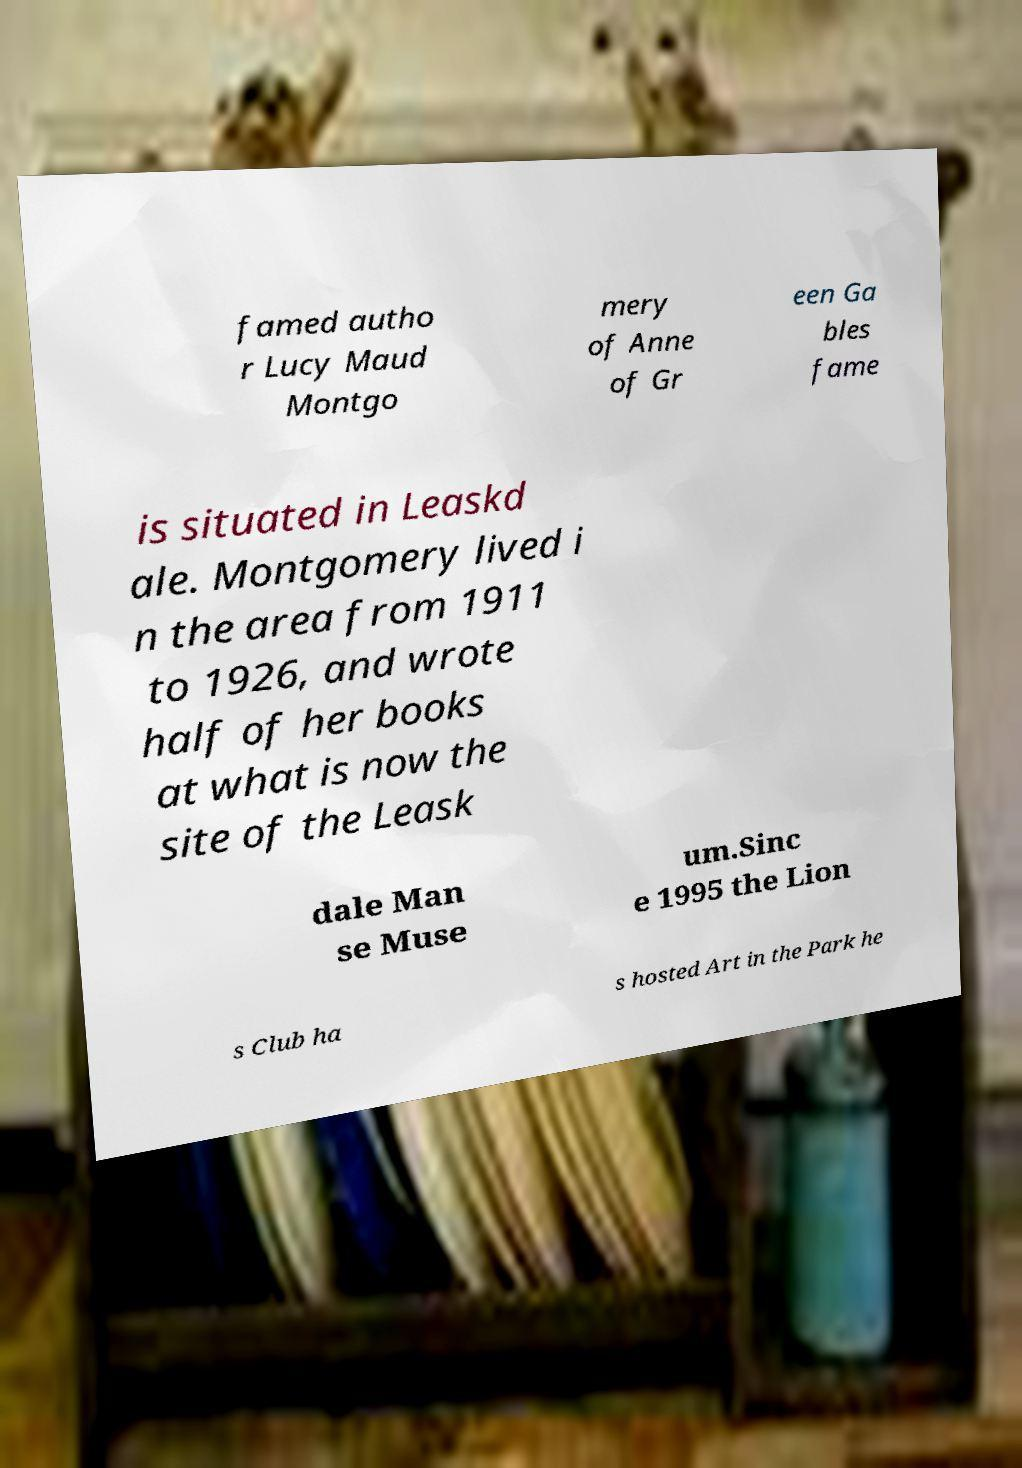Can you accurately transcribe the text from the provided image for me? famed autho r Lucy Maud Montgo mery of Anne of Gr een Ga bles fame is situated in Leaskd ale. Montgomery lived i n the area from 1911 to 1926, and wrote half of her books at what is now the site of the Leask dale Man se Muse um.Sinc e 1995 the Lion s Club ha s hosted Art in the Park he 